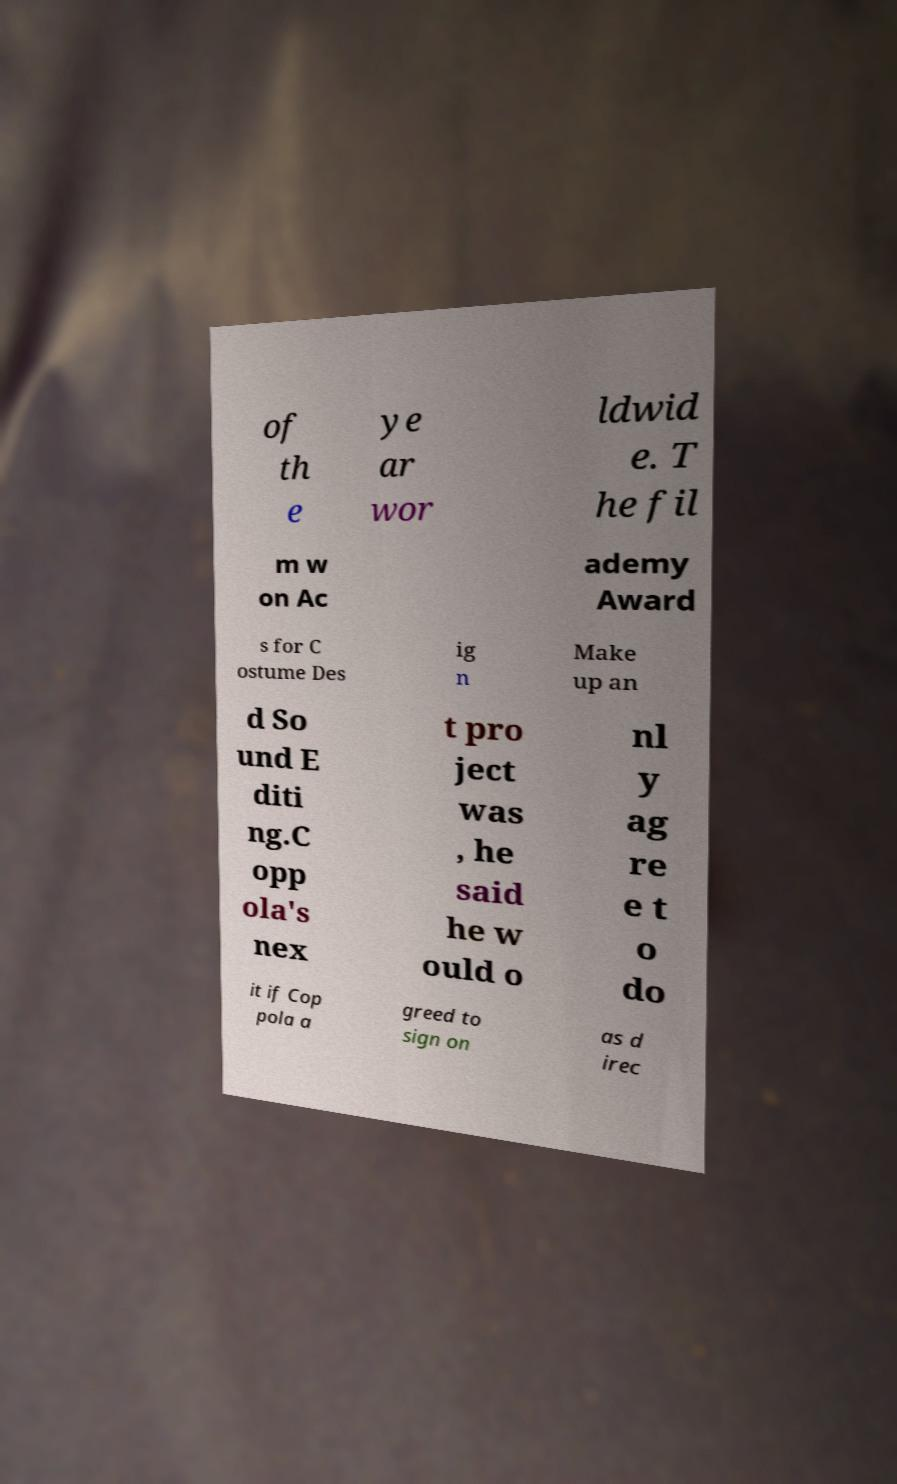Please read and relay the text visible in this image. What does it say? of th e ye ar wor ldwid e. T he fil m w on Ac ademy Award s for C ostume Des ig n Make up an d So und E diti ng.C opp ola's nex t pro ject was , he said he w ould o nl y ag re e t o do it if Cop pola a greed to sign on as d irec 